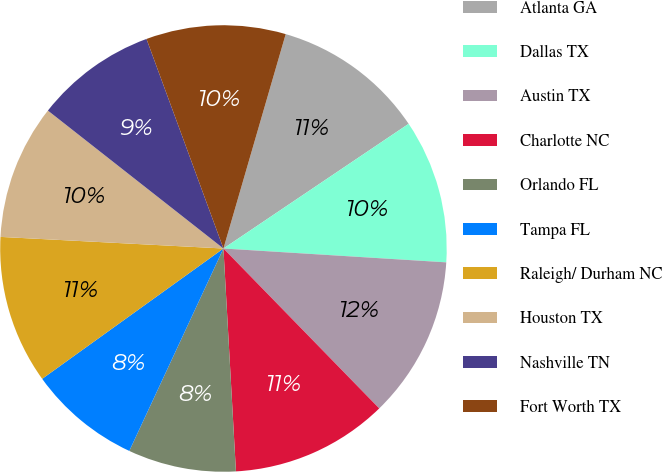Convert chart. <chart><loc_0><loc_0><loc_500><loc_500><pie_chart><fcel>Atlanta GA<fcel>Dallas TX<fcel>Austin TX<fcel>Charlotte NC<fcel>Orlando FL<fcel>Tampa FL<fcel>Raleigh/ Durham NC<fcel>Houston TX<fcel>Nashville TN<fcel>Fort Worth TX<nl><fcel>11.07%<fcel>10.42%<fcel>11.72%<fcel>11.4%<fcel>7.82%<fcel>8.15%<fcel>10.75%<fcel>9.77%<fcel>8.8%<fcel>10.1%<nl></chart> 